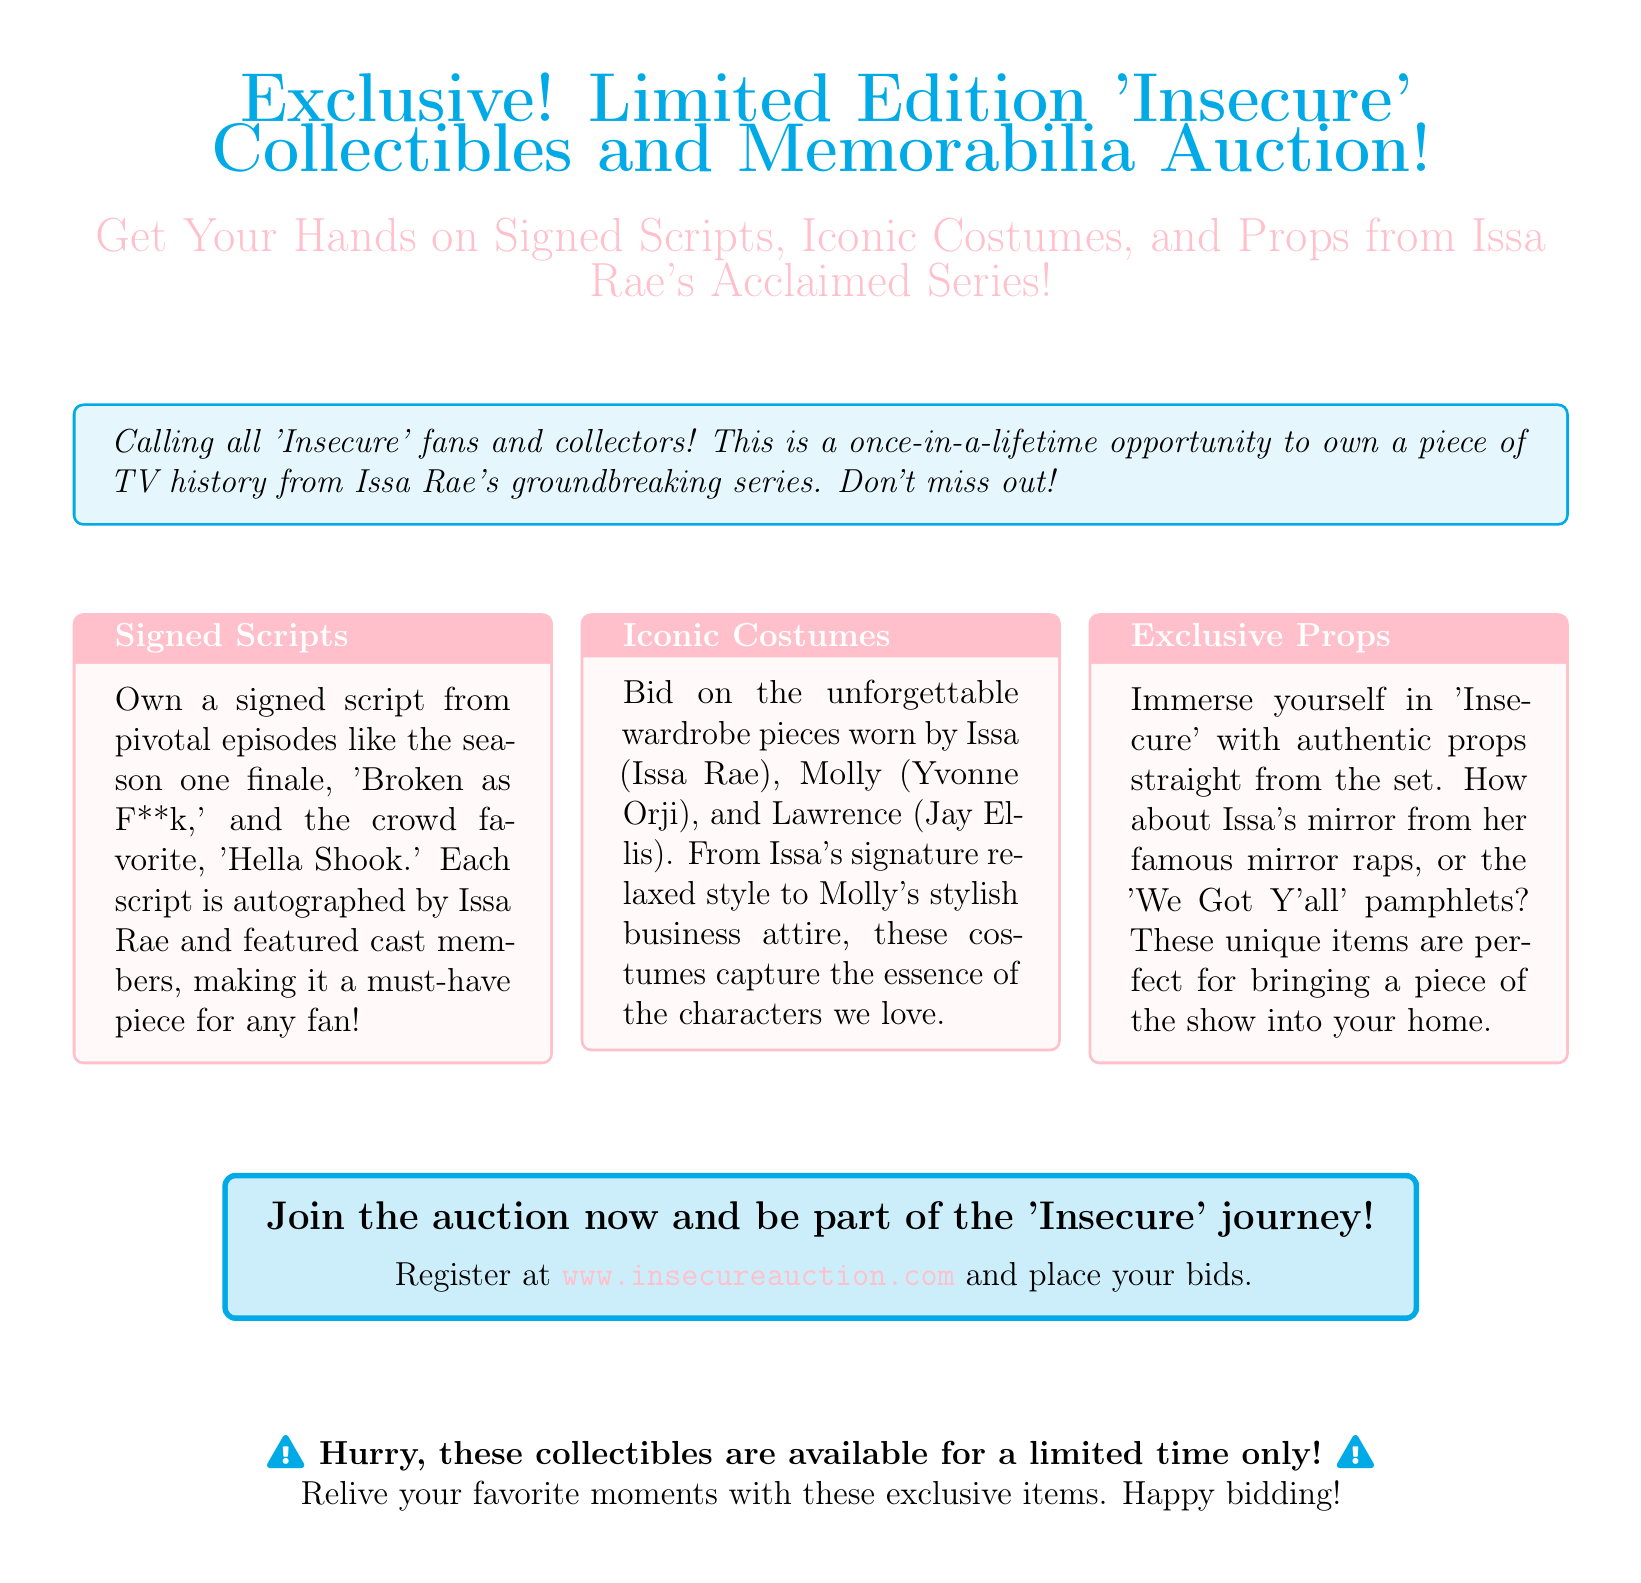What is the auction about? The auction is for limited edition collectibles and memorabilia from the series 'Insecure.'
Answer: Limited Edition 'Insecure' Collectibles and Memorabilia Auction What can you own from the auction? You can own signed scripts, iconic costumes, and props from 'Insecure.'
Answer: Signed scripts, iconic costumes, and props Which episode's script is mentioned? The script from the season one finale 'Broken as F**k' is mentioned.
Answer: 'Broken as F**k' Who signs the scripts? The scripts are signed by Issa Rae and featured cast members.
Answer: Issa Rae and featured cast members What type of costumes are available? The costumes include wardrobe pieces worn by Issa, Molly, and Lawrence.
Answer: Wardrobe pieces worn by Issa, Molly, and Lawrence Where can you register for the auction? You can register at www.insecureauction.com.
Answer: www.insecureauction.com What is emphasized about the collectibles? It is emphasized that these collectibles are available for a limited time only.
Answer: Limited time only What items can you find under Exclusive Props? You can find items like Issa's mirror and 'We Got Y'all' pamphlets.
Answer: Issa's mirror and 'We Got Y'all' pamphlets 